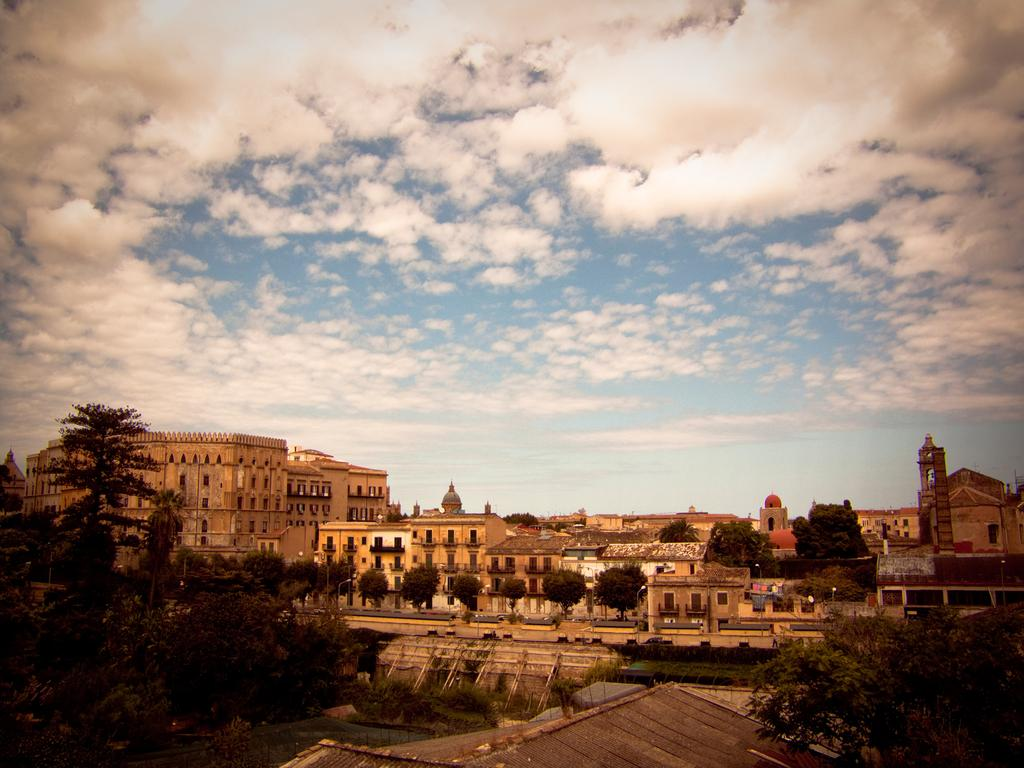What type of structures can be seen in the image? There are buildings, bridges, sheds, and street poles in the image. What natural elements are present in the image? There are trees and water visible in the image. What type of lighting is present in the image? There are street lights in the image. What can be seen in the sky in the background of the image? The sky is visible in the background of the image, and there are clouds present. What type of pancake is being served in the image? There is no pancake present in the image. Is there a tent visible in the image? No, there is no tent present in the image. 